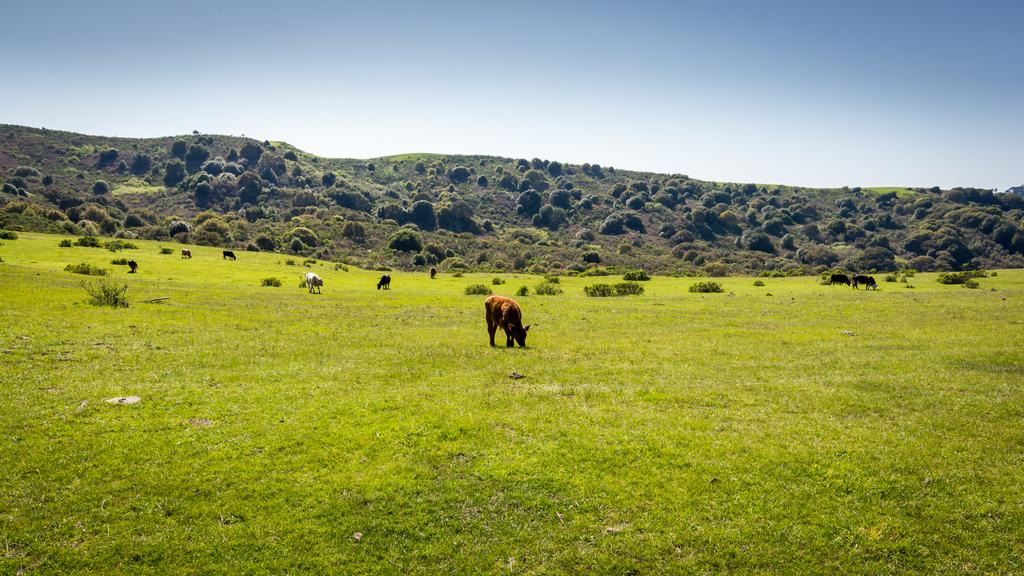What are the animals in the image doing? The animals are grazing in the middle of the image. What can be seen in the background of the image? There are trees in the background of the image. What is visible at the top of the image? The sky is visible at the top of the image. What type of silver is being used to cause trouble for the animals in the image? There is no silver or any indication of trouble for the animals in the image; the animals are simply grazing. 